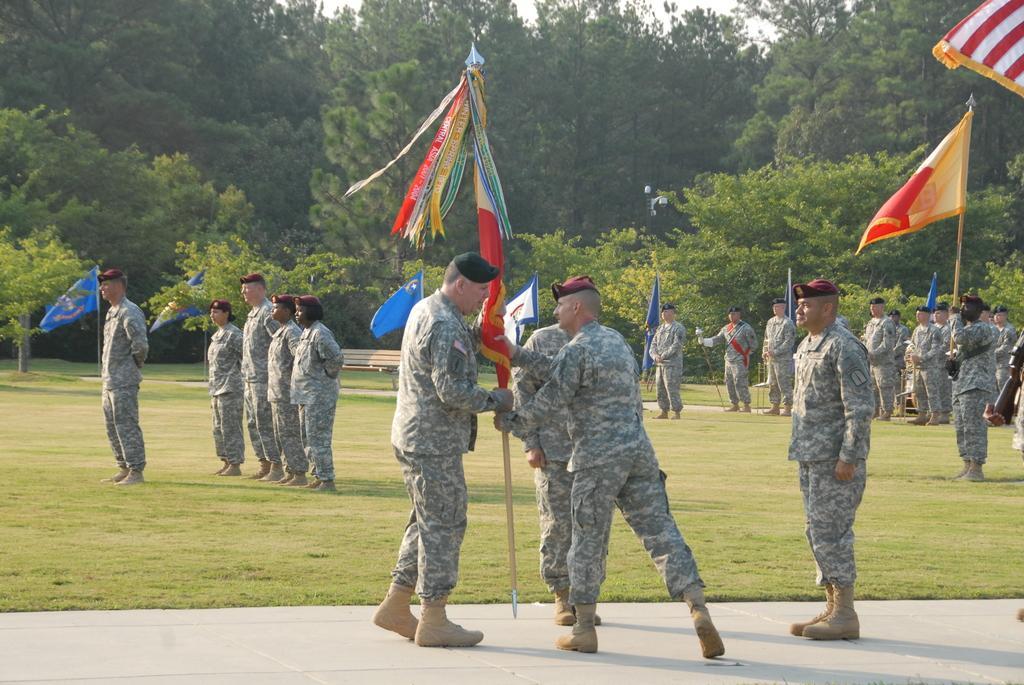In one or two sentences, can you explain what this image depicts? In this image we can see many people. They are wearing caps. In the front two persons are holding flag. Also there is another person holding a flag. In the back there is a person holding stick. On the ground there is grass. In the background there are trees. 